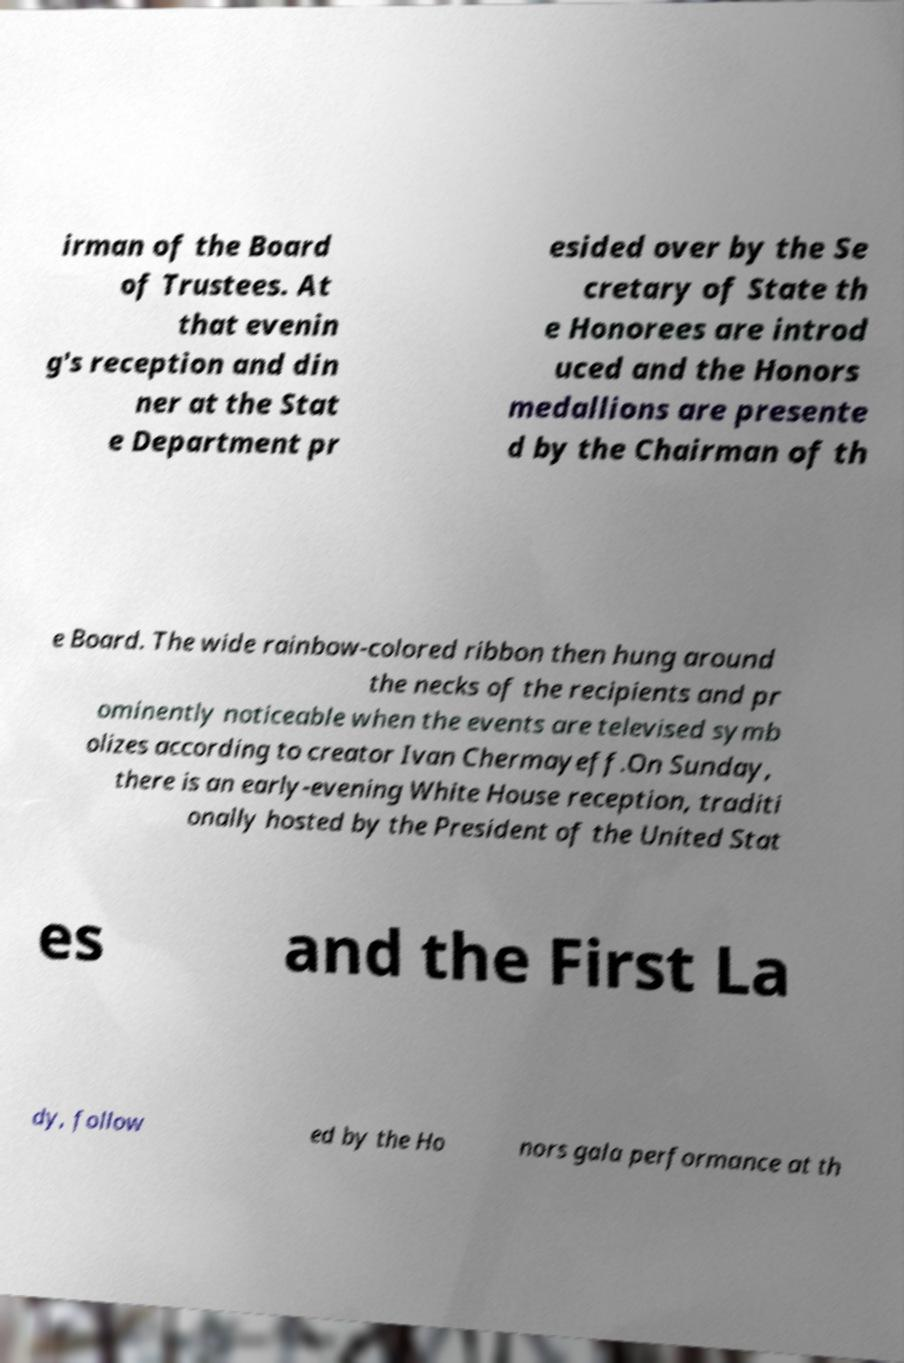Please read and relay the text visible in this image. What does it say? irman of the Board of Trustees. At that evenin g's reception and din ner at the Stat e Department pr esided over by the Se cretary of State th e Honorees are introd uced and the Honors medallions are presente d by the Chairman of th e Board. The wide rainbow-colored ribbon then hung around the necks of the recipients and pr ominently noticeable when the events are televised symb olizes according to creator Ivan Chermayeff.On Sunday, there is an early-evening White House reception, traditi onally hosted by the President of the United Stat es and the First La dy, follow ed by the Ho nors gala performance at th 